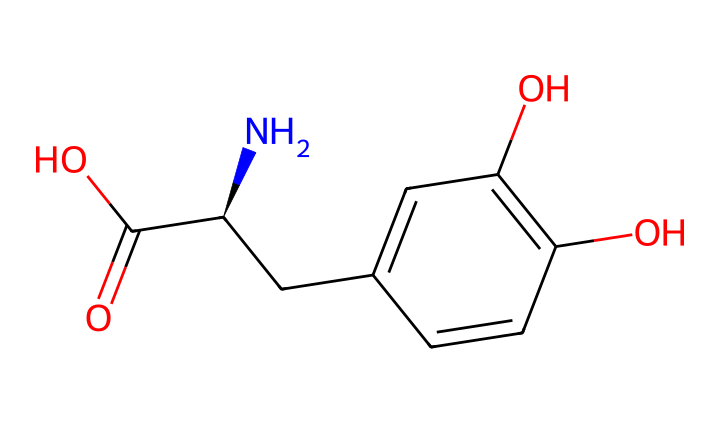What is the molecular formula of L-DOPA? The molecular formula can be determined by counting the number of each type of atom present in the structure. In this case, there are 9 carbon (C) atoms, 11 hydrogen (H) atoms, 1 nitrogen (N) atom, and 4 oxygen (O) atoms. Therefore, the molecular formula is C9H11N1O4.
Answer: C9H11NO4 How many chiral centers are present in L-DOPA? To find the number of chiral centers, we look for carbon atoms that are attached to four different groups. In the structure of L-DOPA, there is one carbon that fits this criteria (the one attached to the amino group, carboxylic acid, and the two different parts of the aromatic structure). Thus, there is one chiral center.
Answer: 1 What type of isomerism does L-DOPA exhibit? The presence of a chiral center in L-DOPA means it can exist in two forms that are non-superimposable mirror images of each other, which is characteristic of enantiomers. Therefore, L-DOPA exhibits optical isomerism.
Answer: optical isomerism Which part of L-DOPA is responsible for its medicinal use? The amino group (-NH2) in L-DOPA facilitates its conversion to dopamine in the brain, which is crucial for treating Parkinson's disease. Hence, this functional group is key to its effectiveness as a medication.
Answer: amino group What functional groups are present in L-DOPA? By analyzing the structure, one can identify various functional groups: specifically, it contains an amino group (-NH2), a carboxylic acid group (-COOH), and hydroxyl groups (-OH) on its aromatic ring. These three functional groups contribute to the properties and behavior of L-DOPA.
Answer: amino, carboxylic acid, hydroxyl How does the spatial arrangement of L-DOPA affect its pharmacological activity? The chiral nature of L-DOPA leads to specific spatial arrangements that influence how the drug interacts with biological targets, particularly receptors and enzymes in the brain. The specific 3D orientation is crucial for binding efficacy and therapeutic effects in treating Parkinson’s disease.
Answer: spatial arrangement 